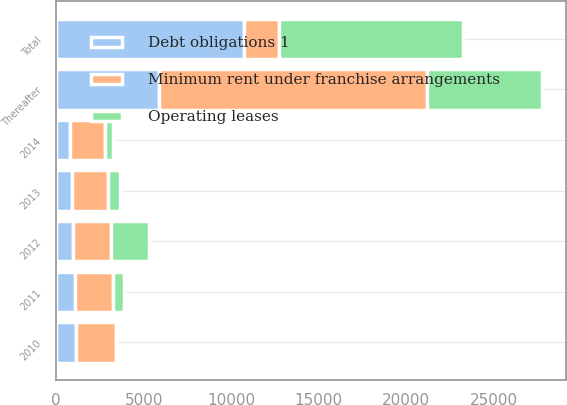<chart> <loc_0><loc_0><loc_500><loc_500><stacked_bar_chart><ecel><fcel>2010<fcel>2011<fcel>2012<fcel>2013<fcel>2014<fcel>Thereafter<fcel>Total<nl><fcel>Debt obligations 1<fcel>1119<fcel>1047<fcel>963<fcel>885<fcel>806<fcel>5897<fcel>10717<nl><fcel>Operating leases<fcel>18<fcel>613<fcel>2188<fcel>658<fcel>460<fcel>6562<fcel>10499<nl><fcel>Minimum rent under franchise arrangements<fcel>2294<fcel>2220<fcel>2156<fcel>2078<fcel>1987<fcel>15278<fcel>2032.5<nl></chart> 